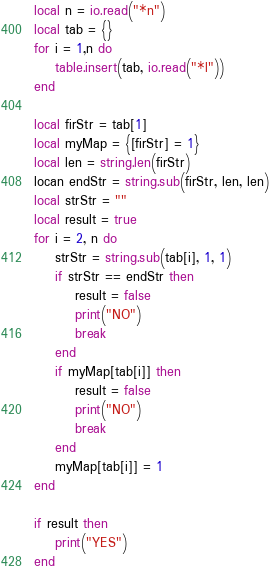<code> <loc_0><loc_0><loc_500><loc_500><_Lua_>local n = io.read("*n")
local tab = {}
for i = 1,n do
    table.insert(tab, io.read("*l"))
end

local firStr = tab[1]
local myMap = {[firStr] = 1}
local len = string.len(firStr)
locan endStr = string.sub(firStr, len, len)
local strStr = ""
local result = true
for i = 2, n do
    strStr = string.sub(tab[i], 1, 1)
    if strStr == endStr then
        result = false
        print("NO")
        break
    end
    if myMap[tab[i]] then
        result = false
        print("NO")
        break
    end
    myMap[tab[i]] = 1
end

if result then
    print("YES")
end
</code> 